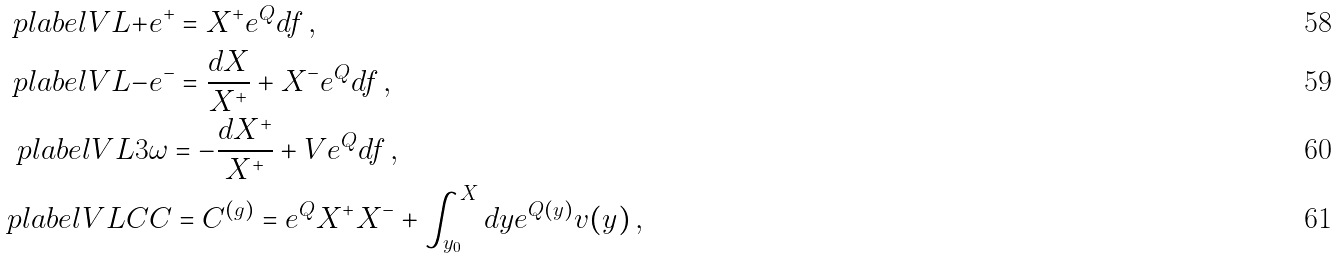Convert formula to latex. <formula><loc_0><loc_0><loc_500><loc_500>\ p l a b e l { V L + } & e ^ { + } = X ^ { + } e ^ { Q } d f \, , \\ \ p l a b e l { V L - } & e ^ { - } = \frac { d X } { X ^ { + } } + X ^ { - } e ^ { Q } d f \, , \\ \ p l a b e l { V L 3 } & \omega = - \frac { d X ^ { + } } { X ^ { + } } + V e ^ { Q } d f \, , \\ \ p l a b e l { V L C } & C = C ^ { ( g ) } = e ^ { Q } X ^ { + } X ^ { - } + \int _ { y _ { 0 } } ^ { X } d y e ^ { Q ( y ) } v ( y ) \, ,</formula> 